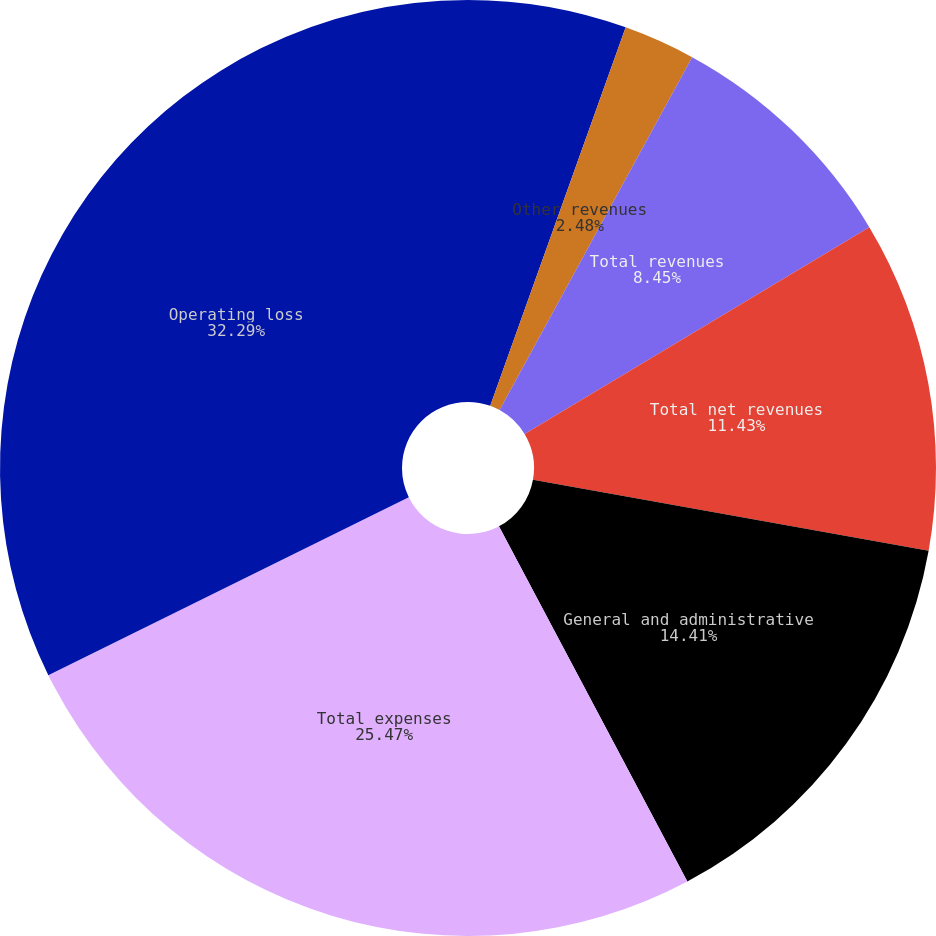<chart> <loc_0><loc_0><loc_500><loc_500><pie_chart><fcel>Net investment income<fcel>Other revenues<fcel>Total revenues<fcel>Total net revenues<fcel>General and administrative<fcel>Total expenses<fcel>Operating loss<nl><fcel>5.47%<fcel>2.48%<fcel>8.45%<fcel>11.43%<fcel>14.41%<fcel>25.47%<fcel>32.3%<nl></chart> 